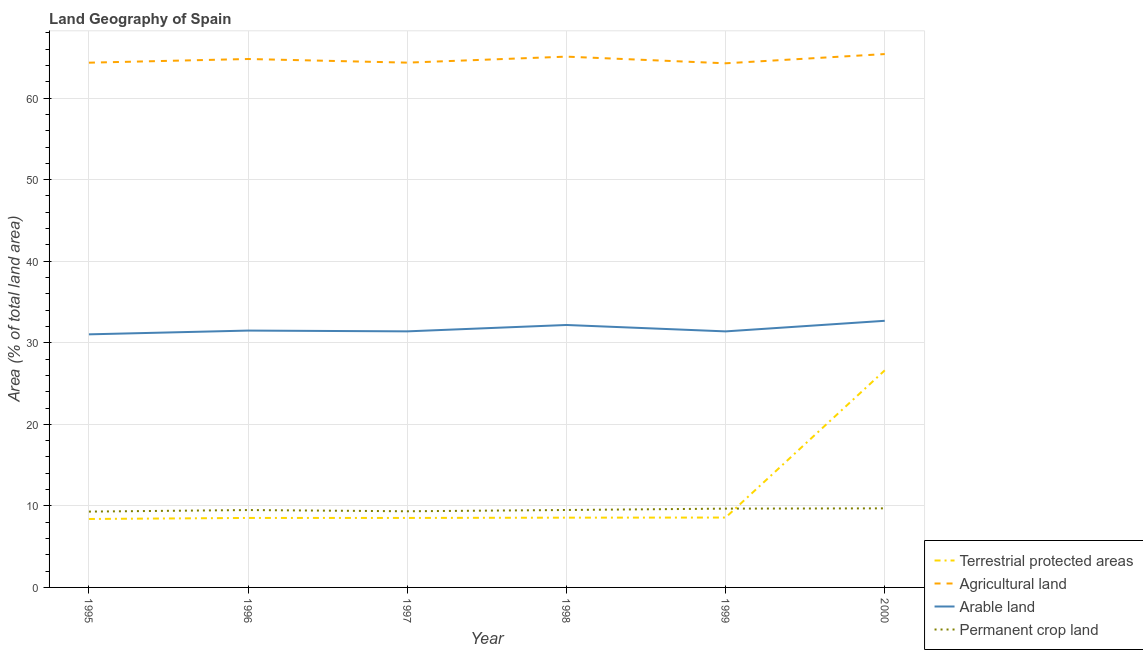What is the percentage of area under arable land in 1997?
Your answer should be very brief. 31.4. Across all years, what is the maximum percentage of land under terrestrial protection?
Keep it short and to the point. 26.62. Across all years, what is the minimum percentage of land under terrestrial protection?
Provide a succinct answer. 8.39. In which year was the percentage of area under permanent crop land maximum?
Ensure brevity in your answer.  2000. In which year was the percentage of area under permanent crop land minimum?
Your response must be concise. 1995. What is the total percentage of area under arable land in the graph?
Ensure brevity in your answer.  190.19. What is the difference between the percentage of area under agricultural land in 1995 and that in 1998?
Provide a short and direct response. -0.74. What is the difference between the percentage of area under agricultural land in 1997 and the percentage of area under permanent crop land in 1995?
Offer a very short reply. 55.05. What is the average percentage of area under arable land per year?
Your answer should be compact. 31.7. In the year 1996, what is the difference between the percentage of area under arable land and percentage of area under permanent crop land?
Offer a very short reply. 22.01. In how many years, is the percentage of area under agricultural land greater than 64 %?
Ensure brevity in your answer.  6. What is the ratio of the percentage of land under terrestrial protection in 1995 to that in 1996?
Ensure brevity in your answer.  0.98. Is the percentage of area under arable land in 1998 less than that in 2000?
Your response must be concise. Yes. What is the difference between the highest and the second highest percentage of area under agricultural land?
Give a very brief answer. 0.31. What is the difference between the highest and the lowest percentage of area under agricultural land?
Provide a succinct answer. 1.13. In how many years, is the percentage of area under arable land greater than the average percentage of area under arable land taken over all years?
Make the answer very short. 2. Does the percentage of land under terrestrial protection monotonically increase over the years?
Your answer should be compact. Yes. Is the percentage of area under permanent crop land strictly greater than the percentage of area under arable land over the years?
Your answer should be very brief. No. Is the percentage of area under agricultural land strictly less than the percentage of area under arable land over the years?
Provide a short and direct response. No. How many lines are there?
Your answer should be compact. 4. What is the difference between two consecutive major ticks on the Y-axis?
Your answer should be very brief. 10. Are the values on the major ticks of Y-axis written in scientific E-notation?
Provide a short and direct response. No. Does the graph contain grids?
Ensure brevity in your answer.  Yes. How many legend labels are there?
Ensure brevity in your answer.  4. What is the title of the graph?
Provide a succinct answer. Land Geography of Spain. What is the label or title of the Y-axis?
Your answer should be compact. Area (% of total land area). What is the Area (% of total land area) of Terrestrial protected areas in 1995?
Provide a short and direct response. 8.39. What is the Area (% of total land area) in Agricultural land in 1995?
Provide a succinct answer. 64.34. What is the Area (% of total land area) in Arable land in 1995?
Ensure brevity in your answer.  31.03. What is the Area (% of total land area) of Permanent crop land in 1995?
Provide a succinct answer. 9.3. What is the Area (% of total land area) in Terrestrial protected areas in 1996?
Make the answer very short. 8.52. What is the Area (% of total land area) in Agricultural land in 1996?
Keep it short and to the point. 64.79. What is the Area (% of total land area) in Arable land in 1996?
Provide a succinct answer. 31.49. What is the Area (% of total land area) of Permanent crop land in 1996?
Your answer should be very brief. 9.49. What is the Area (% of total land area) of Terrestrial protected areas in 1997?
Provide a short and direct response. 8.52. What is the Area (% of total land area) of Agricultural land in 1997?
Offer a terse response. 64.35. What is the Area (% of total land area) in Arable land in 1997?
Your answer should be very brief. 31.4. What is the Area (% of total land area) in Permanent crop land in 1997?
Your answer should be compact. 9.34. What is the Area (% of total land area) of Terrestrial protected areas in 1998?
Make the answer very short. 8.55. What is the Area (% of total land area) in Agricultural land in 1998?
Provide a short and direct response. 65.08. What is the Area (% of total land area) in Arable land in 1998?
Ensure brevity in your answer.  32.18. What is the Area (% of total land area) in Permanent crop land in 1998?
Your response must be concise. 9.49. What is the Area (% of total land area) of Terrestrial protected areas in 1999?
Keep it short and to the point. 8.57. What is the Area (% of total land area) in Agricultural land in 1999?
Provide a short and direct response. 64.27. What is the Area (% of total land area) of Arable land in 1999?
Provide a short and direct response. 31.39. What is the Area (% of total land area) in Permanent crop land in 1999?
Offer a very short reply. 9.66. What is the Area (% of total land area) in Terrestrial protected areas in 2000?
Your answer should be very brief. 26.62. What is the Area (% of total land area) in Agricultural land in 2000?
Your answer should be compact. 65.4. What is the Area (% of total land area) in Arable land in 2000?
Your response must be concise. 32.69. What is the Area (% of total land area) in Permanent crop land in 2000?
Offer a terse response. 9.69. Across all years, what is the maximum Area (% of total land area) in Terrestrial protected areas?
Your answer should be very brief. 26.62. Across all years, what is the maximum Area (% of total land area) in Agricultural land?
Offer a terse response. 65.4. Across all years, what is the maximum Area (% of total land area) of Arable land?
Provide a short and direct response. 32.69. Across all years, what is the maximum Area (% of total land area) of Permanent crop land?
Your answer should be very brief. 9.69. Across all years, what is the minimum Area (% of total land area) in Terrestrial protected areas?
Make the answer very short. 8.39. Across all years, what is the minimum Area (% of total land area) in Agricultural land?
Offer a terse response. 64.27. Across all years, what is the minimum Area (% of total land area) of Arable land?
Provide a succinct answer. 31.03. Across all years, what is the minimum Area (% of total land area) in Permanent crop land?
Your answer should be very brief. 9.3. What is the total Area (% of total land area) in Terrestrial protected areas in the graph?
Your response must be concise. 69.17. What is the total Area (% of total land area) in Agricultural land in the graph?
Your answer should be very brief. 388.22. What is the total Area (% of total land area) in Arable land in the graph?
Your answer should be compact. 190.19. What is the total Area (% of total land area) of Permanent crop land in the graph?
Keep it short and to the point. 56.98. What is the difference between the Area (% of total land area) in Terrestrial protected areas in 1995 and that in 1996?
Provide a succinct answer. -0.13. What is the difference between the Area (% of total land area) of Agricultural land in 1995 and that in 1996?
Offer a terse response. -0.45. What is the difference between the Area (% of total land area) of Arable land in 1995 and that in 1996?
Give a very brief answer. -0.46. What is the difference between the Area (% of total land area) of Permanent crop land in 1995 and that in 1996?
Your answer should be very brief. -0.19. What is the difference between the Area (% of total land area) in Terrestrial protected areas in 1995 and that in 1997?
Ensure brevity in your answer.  -0.13. What is the difference between the Area (% of total land area) in Agricultural land in 1995 and that in 1997?
Offer a very short reply. -0.01. What is the difference between the Area (% of total land area) of Arable land in 1995 and that in 1997?
Your answer should be compact. -0.37. What is the difference between the Area (% of total land area) of Permanent crop land in 1995 and that in 1997?
Your answer should be very brief. -0.04. What is the difference between the Area (% of total land area) in Terrestrial protected areas in 1995 and that in 1998?
Provide a succinct answer. -0.16. What is the difference between the Area (% of total land area) of Agricultural land in 1995 and that in 1998?
Provide a short and direct response. -0.74. What is the difference between the Area (% of total land area) in Arable land in 1995 and that in 1998?
Offer a terse response. -1.15. What is the difference between the Area (% of total land area) in Permanent crop land in 1995 and that in 1998?
Your answer should be very brief. -0.2. What is the difference between the Area (% of total land area) in Terrestrial protected areas in 1995 and that in 1999?
Provide a succinct answer. -0.18. What is the difference between the Area (% of total land area) of Agricultural land in 1995 and that in 1999?
Ensure brevity in your answer.  0.07. What is the difference between the Area (% of total land area) in Arable land in 1995 and that in 1999?
Ensure brevity in your answer.  -0.36. What is the difference between the Area (% of total land area) of Permanent crop land in 1995 and that in 1999?
Give a very brief answer. -0.36. What is the difference between the Area (% of total land area) of Terrestrial protected areas in 1995 and that in 2000?
Your response must be concise. -18.23. What is the difference between the Area (% of total land area) in Agricultural land in 1995 and that in 2000?
Ensure brevity in your answer.  -1.06. What is the difference between the Area (% of total land area) in Arable land in 1995 and that in 2000?
Offer a terse response. -1.66. What is the difference between the Area (% of total land area) of Permanent crop land in 1995 and that in 2000?
Offer a terse response. -0.4. What is the difference between the Area (% of total land area) of Terrestrial protected areas in 1996 and that in 1997?
Your response must be concise. -0. What is the difference between the Area (% of total land area) of Agricultural land in 1996 and that in 1997?
Your answer should be very brief. 0.45. What is the difference between the Area (% of total land area) in Arable land in 1996 and that in 1997?
Provide a succinct answer. 0.1. What is the difference between the Area (% of total land area) of Permanent crop land in 1996 and that in 1997?
Your answer should be compact. 0.15. What is the difference between the Area (% of total land area) in Terrestrial protected areas in 1996 and that in 1998?
Provide a short and direct response. -0.03. What is the difference between the Area (% of total land area) in Agricultural land in 1996 and that in 1998?
Your answer should be compact. -0.29. What is the difference between the Area (% of total land area) of Arable land in 1996 and that in 1998?
Make the answer very short. -0.68. What is the difference between the Area (% of total land area) of Permanent crop land in 1996 and that in 1998?
Your answer should be compact. -0.01. What is the difference between the Area (% of total land area) in Terrestrial protected areas in 1996 and that in 1999?
Provide a succinct answer. -0.05. What is the difference between the Area (% of total land area) of Agricultural land in 1996 and that in 1999?
Offer a very short reply. 0.53. What is the difference between the Area (% of total land area) in Arable land in 1996 and that in 1999?
Your answer should be very brief. 0.1. What is the difference between the Area (% of total land area) in Permanent crop land in 1996 and that in 1999?
Make the answer very short. -0.17. What is the difference between the Area (% of total land area) of Terrestrial protected areas in 1996 and that in 2000?
Your answer should be very brief. -18.1. What is the difference between the Area (% of total land area) in Agricultural land in 1996 and that in 2000?
Provide a succinct answer. -0.6. What is the difference between the Area (% of total land area) in Arable land in 1996 and that in 2000?
Your answer should be very brief. -1.2. What is the difference between the Area (% of total land area) of Permanent crop land in 1996 and that in 2000?
Your answer should be very brief. -0.21. What is the difference between the Area (% of total land area) of Terrestrial protected areas in 1997 and that in 1998?
Provide a short and direct response. -0.03. What is the difference between the Area (% of total land area) in Agricultural land in 1997 and that in 1998?
Your response must be concise. -0.74. What is the difference between the Area (% of total land area) of Arable land in 1997 and that in 1998?
Offer a terse response. -0.78. What is the difference between the Area (% of total land area) in Permanent crop land in 1997 and that in 1998?
Provide a succinct answer. -0.16. What is the difference between the Area (% of total land area) in Terrestrial protected areas in 1997 and that in 1999?
Your answer should be very brief. -0.05. What is the difference between the Area (% of total land area) in Arable land in 1997 and that in 1999?
Keep it short and to the point. 0. What is the difference between the Area (% of total land area) in Permanent crop land in 1997 and that in 1999?
Keep it short and to the point. -0.32. What is the difference between the Area (% of total land area) in Terrestrial protected areas in 1997 and that in 2000?
Make the answer very short. -18.1. What is the difference between the Area (% of total land area) of Agricultural land in 1997 and that in 2000?
Provide a short and direct response. -1.05. What is the difference between the Area (% of total land area) in Arable land in 1997 and that in 2000?
Provide a succinct answer. -1.29. What is the difference between the Area (% of total land area) in Permanent crop land in 1997 and that in 2000?
Your answer should be compact. -0.36. What is the difference between the Area (% of total land area) in Terrestrial protected areas in 1998 and that in 1999?
Your answer should be very brief. -0.01. What is the difference between the Area (% of total land area) of Agricultural land in 1998 and that in 1999?
Provide a succinct answer. 0.82. What is the difference between the Area (% of total land area) in Arable land in 1998 and that in 1999?
Your answer should be very brief. 0.78. What is the difference between the Area (% of total land area) of Permanent crop land in 1998 and that in 1999?
Provide a short and direct response. -0.17. What is the difference between the Area (% of total land area) in Terrestrial protected areas in 1998 and that in 2000?
Your answer should be very brief. -18.06. What is the difference between the Area (% of total land area) in Agricultural land in 1998 and that in 2000?
Your response must be concise. -0.31. What is the difference between the Area (% of total land area) in Arable land in 1998 and that in 2000?
Your answer should be very brief. -0.51. What is the difference between the Area (% of total land area) of Permanent crop land in 1998 and that in 2000?
Ensure brevity in your answer.  -0.2. What is the difference between the Area (% of total land area) in Terrestrial protected areas in 1999 and that in 2000?
Your answer should be compact. -18.05. What is the difference between the Area (% of total land area) of Agricultural land in 1999 and that in 2000?
Make the answer very short. -1.13. What is the difference between the Area (% of total land area) in Arable land in 1999 and that in 2000?
Give a very brief answer. -1.3. What is the difference between the Area (% of total land area) in Permanent crop land in 1999 and that in 2000?
Provide a short and direct response. -0.03. What is the difference between the Area (% of total land area) of Terrestrial protected areas in 1995 and the Area (% of total land area) of Agricultural land in 1996?
Give a very brief answer. -56.4. What is the difference between the Area (% of total land area) in Terrestrial protected areas in 1995 and the Area (% of total land area) in Arable land in 1996?
Keep it short and to the point. -23.1. What is the difference between the Area (% of total land area) in Terrestrial protected areas in 1995 and the Area (% of total land area) in Permanent crop land in 1996?
Make the answer very short. -1.1. What is the difference between the Area (% of total land area) of Agricultural land in 1995 and the Area (% of total land area) of Arable land in 1996?
Offer a terse response. 32.85. What is the difference between the Area (% of total land area) of Agricultural land in 1995 and the Area (% of total land area) of Permanent crop land in 1996?
Provide a succinct answer. 54.85. What is the difference between the Area (% of total land area) in Arable land in 1995 and the Area (% of total land area) in Permanent crop land in 1996?
Your answer should be very brief. 21.54. What is the difference between the Area (% of total land area) in Terrestrial protected areas in 1995 and the Area (% of total land area) in Agricultural land in 1997?
Your answer should be very brief. -55.95. What is the difference between the Area (% of total land area) in Terrestrial protected areas in 1995 and the Area (% of total land area) in Arable land in 1997?
Ensure brevity in your answer.  -23.01. What is the difference between the Area (% of total land area) of Terrestrial protected areas in 1995 and the Area (% of total land area) of Permanent crop land in 1997?
Give a very brief answer. -0.95. What is the difference between the Area (% of total land area) of Agricultural land in 1995 and the Area (% of total land area) of Arable land in 1997?
Your response must be concise. 32.94. What is the difference between the Area (% of total land area) of Agricultural land in 1995 and the Area (% of total land area) of Permanent crop land in 1997?
Provide a short and direct response. 55. What is the difference between the Area (% of total land area) in Arable land in 1995 and the Area (% of total land area) in Permanent crop land in 1997?
Your answer should be compact. 21.69. What is the difference between the Area (% of total land area) of Terrestrial protected areas in 1995 and the Area (% of total land area) of Agricultural land in 1998?
Keep it short and to the point. -56.69. What is the difference between the Area (% of total land area) of Terrestrial protected areas in 1995 and the Area (% of total land area) of Arable land in 1998?
Give a very brief answer. -23.79. What is the difference between the Area (% of total land area) in Terrestrial protected areas in 1995 and the Area (% of total land area) in Permanent crop land in 1998?
Your answer should be very brief. -1.1. What is the difference between the Area (% of total land area) of Agricultural land in 1995 and the Area (% of total land area) of Arable land in 1998?
Provide a short and direct response. 32.16. What is the difference between the Area (% of total land area) in Agricultural land in 1995 and the Area (% of total land area) in Permanent crop land in 1998?
Ensure brevity in your answer.  54.85. What is the difference between the Area (% of total land area) of Arable land in 1995 and the Area (% of total land area) of Permanent crop land in 1998?
Offer a terse response. 21.54. What is the difference between the Area (% of total land area) of Terrestrial protected areas in 1995 and the Area (% of total land area) of Agricultural land in 1999?
Provide a succinct answer. -55.87. What is the difference between the Area (% of total land area) in Terrestrial protected areas in 1995 and the Area (% of total land area) in Arable land in 1999?
Make the answer very short. -23. What is the difference between the Area (% of total land area) of Terrestrial protected areas in 1995 and the Area (% of total land area) of Permanent crop land in 1999?
Your answer should be very brief. -1.27. What is the difference between the Area (% of total land area) in Agricultural land in 1995 and the Area (% of total land area) in Arable land in 1999?
Provide a succinct answer. 32.95. What is the difference between the Area (% of total land area) of Agricultural land in 1995 and the Area (% of total land area) of Permanent crop land in 1999?
Offer a very short reply. 54.68. What is the difference between the Area (% of total land area) of Arable land in 1995 and the Area (% of total land area) of Permanent crop land in 1999?
Your answer should be compact. 21.37. What is the difference between the Area (% of total land area) in Terrestrial protected areas in 1995 and the Area (% of total land area) in Agricultural land in 2000?
Your answer should be very brief. -57. What is the difference between the Area (% of total land area) in Terrestrial protected areas in 1995 and the Area (% of total land area) in Arable land in 2000?
Your answer should be compact. -24.3. What is the difference between the Area (% of total land area) in Terrestrial protected areas in 1995 and the Area (% of total land area) in Permanent crop land in 2000?
Your response must be concise. -1.3. What is the difference between the Area (% of total land area) in Agricultural land in 1995 and the Area (% of total land area) in Arable land in 2000?
Provide a short and direct response. 31.65. What is the difference between the Area (% of total land area) of Agricultural land in 1995 and the Area (% of total land area) of Permanent crop land in 2000?
Give a very brief answer. 54.65. What is the difference between the Area (% of total land area) of Arable land in 1995 and the Area (% of total land area) of Permanent crop land in 2000?
Provide a succinct answer. 21.34. What is the difference between the Area (% of total land area) of Terrestrial protected areas in 1996 and the Area (% of total land area) of Agricultural land in 1997?
Offer a very short reply. -55.83. What is the difference between the Area (% of total land area) of Terrestrial protected areas in 1996 and the Area (% of total land area) of Arable land in 1997?
Provide a succinct answer. -22.88. What is the difference between the Area (% of total land area) of Terrestrial protected areas in 1996 and the Area (% of total land area) of Permanent crop land in 1997?
Make the answer very short. -0.82. What is the difference between the Area (% of total land area) of Agricultural land in 1996 and the Area (% of total land area) of Arable land in 1997?
Your response must be concise. 33.39. What is the difference between the Area (% of total land area) of Agricultural land in 1996 and the Area (% of total land area) of Permanent crop land in 1997?
Offer a terse response. 55.45. What is the difference between the Area (% of total land area) in Arable land in 1996 and the Area (% of total land area) in Permanent crop land in 1997?
Make the answer very short. 22.16. What is the difference between the Area (% of total land area) of Terrestrial protected areas in 1996 and the Area (% of total land area) of Agricultural land in 1998?
Give a very brief answer. -56.56. What is the difference between the Area (% of total land area) of Terrestrial protected areas in 1996 and the Area (% of total land area) of Arable land in 1998?
Your answer should be very brief. -23.66. What is the difference between the Area (% of total land area) of Terrestrial protected areas in 1996 and the Area (% of total land area) of Permanent crop land in 1998?
Ensure brevity in your answer.  -0.97. What is the difference between the Area (% of total land area) in Agricultural land in 1996 and the Area (% of total land area) in Arable land in 1998?
Ensure brevity in your answer.  32.61. What is the difference between the Area (% of total land area) of Agricultural land in 1996 and the Area (% of total land area) of Permanent crop land in 1998?
Give a very brief answer. 55.3. What is the difference between the Area (% of total land area) of Arable land in 1996 and the Area (% of total land area) of Permanent crop land in 1998?
Make the answer very short. 22. What is the difference between the Area (% of total land area) in Terrestrial protected areas in 1996 and the Area (% of total land area) in Agricultural land in 1999?
Your answer should be very brief. -55.75. What is the difference between the Area (% of total land area) in Terrestrial protected areas in 1996 and the Area (% of total land area) in Arable land in 1999?
Your answer should be very brief. -22.87. What is the difference between the Area (% of total land area) of Terrestrial protected areas in 1996 and the Area (% of total land area) of Permanent crop land in 1999?
Ensure brevity in your answer.  -1.14. What is the difference between the Area (% of total land area) in Agricultural land in 1996 and the Area (% of total land area) in Arable land in 1999?
Your answer should be compact. 33.4. What is the difference between the Area (% of total land area) of Agricultural land in 1996 and the Area (% of total land area) of Permanent crop land in 1999?
Give a very brief answer. 55.13. What is the difference between the Area (% of total land area) of Arable land in 1996 and the Area (% of total land area) of Permanent crop land in 1999?
Your answer should be very brief. 21.83. What is the difference between the Area (% of total land area) in Terrestrial protected areas in 1996 and the Area (% of total land area) in Agricultural land in 2000?
Your response must be concise. -56.88. What is the difference between the Area (% of total land area) of Terrestrial protected areas in 1996 and the Area (% of total land area) of Arable land in 2000?
Keep it short and to the point. -24.17. What is the difference between the Area (% of total land area) of Terrestrial protected areas in 1996 and the Area (% of total land area) of Permanent crop land in 2000?
Your answer should be compact. -1.17. What is the difference between the Area (% of total land area) in Agricultural land in 1996 and the Area (% of total land area) in Arable land in 2000?
Your response must be concise. 32.1. What is the difference between the Area (% of total land area) in Agricultural land in 1996 and the Area (% of total land area) in Permanent crop land in 2000?
Offer a terse response. 55.1. What is the difference between the Area (% of total land area) of Arable land in 1996 and the Area (% of total land area) of Permanent crop land in 2000?
Your answer should be compact. 21.8. What is the difference between the Area (% of total land area) in Terrestrial protected areas in 1997 and the Area (% of total land area) in Agricultural land in 1998?
Provide a short and direct response. -56.56. What is the difference between the Area (% of total land area) in Terrestrial protected areas in 1997 and the Area (% of total land area) in Arable land in 1998?
Ensure brevity in your answer.  -23.66. What is the difference between the Area (% of total land area) of Terrestrial protected areas in 1997 and the Area (% of total land area) of Permanent crop land in 1998?
Keep it short and to the point. -0.97. What is the difference between the Area (% of total land area) in Agricultural land in 1997 and the Area (% of total land area) in Arable land in 1998?
Your answer should be very brief. 32.17. What is the difference between the Area (% of total land area) in Agricultural land in 1997 and the Area (% of total land area) in Permanent crop land in 1998?
Your answer should be compact. 54.85. What is the difference between the Area (% of total land area) of Arable land in 1997 and the Area (% of total land area) of Permanent crop land in 1998?
Keep it short and to the point. 21.9. What is the difference between the Area (% of total land area) in Terrestrial protected areas in 1997 and the Area (% of total land area) in Agricultural land in 1999?
Your response must be concise. -55.75. What is the difference between the Area (% of total land area) of Terrestrial protected areas in 1997 and the Area (% of total land area) of Arable land in 1999?
Give a very brief answer. -22.87. What is the difference between the Area (% of total land area) in Terrestrial protected areas in 1997 and the Area (% of total land area) in Permanent crop land in 1999?
Provide a short and direct response. -1.14. What is the difference between the Area (% of total land area) of Agricultural land in 1997 and the Area (% of total land area) of Arable land in 1999?
Your answer should be compact. 32.95. What is the difference between the Area (% of total land area) of Agricultural land in 1997 and the Area (% of total land area) of Permanent crop land in 1999?
Offer a very short reply. 54.68. What is the difference between the Area (% of total land area) in Arable land in 1997 and the Area (% of total land area) in Permanent crop land in 1999?
Your response must be concise. 21.74. What is the difference between the Area (% of total land area) in Terrestrial protected areas in 1997 and the Area (% of total land area) in Agricultural land in 2000?
Make the answer very short. -56.88. What is the difference between the Area (% of total land area) of Terrestrial protected areas in 1997 and the Area (% of total land area) of Arable land in 2000?
Offer a terse response. -24.17. What is the difference between the Area (% of total land area) of Terrestrial protected areas in 1997 and the Area (% of total land area) of Permanent crop land in 2000?
Make the answer very short. -1.17. What is the difference between the Area (% of total land area) of Agricultural land in 1997 and the Area (% of total land area) of Arable land in 2000?
Give a very brief answer. 31.65. What is the difference between the Area (% of total land area) of Agricultural land in 1997 and the Area (% of total land area) of Permanent crop land in 2000?
Provide a short and direct response. 54.65. What is the difference between the Area (% of total land area) in Arable land in 1997 and the Area (% of total land area) in Permanent crop land in 2000?
Keep it short and to the point. 21.7. What is the difference between the Area (% of total land area) in Terrestrial protected areas in 1998 and the Area (% of total land area) in Agricultural land in 1999?
Offer a terse response. -55.71. What is the difference between the Area (% of total land area) of Terrestrial protected areas in 1998 and the Area (% of total land area) of Arable land in 1999?
Provide a succinct answer. -22.84. What is the difference between the Area (% of total land area) in Terrestrial protected areas in 1998 and the Area (% of total land area) in Permanent crop land in 1999?
Give a very brief answer. -1.11. What is the difference between the Area (% of total land area) of Agricultural land in 1998 and the Area (% of total land area) of Arable land in 1999?
Your answer should be compact. 33.69. What is the difference between the Area (% of total land area) in Agricultural land in 1998 and the Area (% of total land area) in Permanent crop land in 1999?
Give a very brief answer. 55.42. What is the difference between the Area (% of total land area) in Arable land in 1998 and the Area (% of total land area) in Permanent crop land in 1999?
Ensure brevity in your answer.  22.52. What is the difference between the Area (% of total land area) of Terrestrial protected areas in 1998 and the Area (% of total land area) of Agricultural land in 2000?
Keep it short and to the point. -56.84. What is the difference between the Area (% of total land area) in Terrestrial protected areas in 1998 and the Area (% of total land area) in Arable land in 2000?
Your answer should be compact. -24.14. What is the difference between the Area (% of total land area) of Terrestrial protected areas in 1998 and the Area (% of total land area) of Permanent crop land in 2000?
Provide a short and direct response. -1.14. What is the difference between the Area (% of total land area) of Agricultural land in 1998 and the Area (% of total land area) of Arable land in 2000?
Provide a short and direct response. 32.39. What is the difference between the Area (% of total land area) in Agricultural land in 1998 and the Area (% of total land area) in Permanent crop land in 2000?
Provide a short and direct response. 55.39. What is the difference between the Area (% of total land area) in Arable land in 1998 and the Area (% of total land area) in Permanent crop land in 2000?
Your answer should be very brief. 22.48. What is the difference between the Area (% of total land area) of Terrestrial protected areas in 1999 and the Area (% of total land area) of Agricultural land in 2000?
Your answer should be very brief. -56.83. What is the difference between the Area (% of total land area) of Terrestrial protected areas in 1999 and the Area (% of total land area) of Arable land in 2000?
Provide a short and direct response. -24.12. What is the difference between the Area (% of total land area) in Terrestrial protected areas in 1999 and the Area (% of total land area) in Permanent crop land in 2000?
Your response must be concise. -1.13. What is the difference between the Area (% of total land area) of Agricultural land in 1999 and the Area (% of total land area) of Arable land in 2000?
Your answer should be very brief. 31.57. What is the difference between the Area (% of total land area) of Agricultural land in 1999 and the Area (% of total land area) of Permanent crop land in 2000?
Your answer should be very brief. 54.57. What is the difference between the Area (% of total land area) in Arable land in 1999 and the Area (% of total land area) in Permanent crop land in 2000?
Your answer should be very brief. 21.7. What is the average Area (% of total land area) in Terrestrial protected areas per year?
Keep it short and to the point. 11.53. What is the average Area (% of total land area) in Agricultural land per year?
Give a very brief answer. 64.7. What is the average Area (% of total land area) of Arable land per year?
Your answer should be very brief. 31.7. What is the average Area (% of total land area) of Permanent crop land per year?
Provide a succinct answer. 9.5. In the year 1995, what is the difference between the Area (% of total land area) of Terrestrial protected areas and Area (% of total land area) of Agricultural land?
Keep it short and to the point. -55.95. In the year 1995, what is the difference between the Area (% of total land area) of Terrestrial protected areas and Area (% of total land area) of Arable land?
Ensure brevity in your answer.  -22.64. In the year 1995, what is the difference between the Area (% of total land area) in Terrestrial protected areas and Area (% of total land area) in Permanent crop land?
Ensure brevity in your answer.  -0.91. In the year 1995, what is the difference between the Area (% of total land area) in Agricultural land and Area (% of total land area) in Arable land?
Give a very brief answer. 33.31. In the year 1995, what is the difference between the Area (% of total land area) in Agricultural land and Area (% of total land area) in Permanent crop land?
Your answer should be compact. 55.04. In the year 1995, what is the difference between the Area (% of total land area) in Arable land and Area (% of total land area) in Permanent crop land?
Your answer should be very brief. 21.73. In the year 1996, what is the difference between the Area (% of total land area) in Terrestrial protected areas and Area (% of total land area) in Agricultural land?
Provide a short and direct response. -56.27. In the year 1996, what is the difference between the Area (% of total land area) in Terrestrial protected areas and Area (% of total land area) in Arable land?
Offer a very short reply. -22.97. In the year 1996, what is the difference between the Area (% of total land area) of Terrestrial protected areas and Area (% of total land area) of Permanent crop land?
Make the answer very short. -0.97. In the year 1996, what is the difference between the Area (% of total land area) of Agricultural land and Area (% of total land area) of Arable land?
Offer a terse response. 33.3. In the year 1996, what is the difference between the Area (% of total land area) of Agricultural land and Area (% of total land area) of Permanent crop land?
Your answer should be very brief. 55.3. In the year 1996, what is the difference between the Area (% of total land area) of Arable land and Area (% of total land area) of Permanent crop land?
Ensure brevity in your answer.  22.01. In the year 1997, what is the difference between the Area (% of total land area) of Terrestrial protected areas and Area (% of total land area) of Agricultural land?
Your answer should be compact. -55.83. In the year 1997, what is the difference between the Area (% of total land area) of Terrestrial protected areas and Area (% of total land area) of Arable land?
Keep it short and to the point. -22.88. In the year 1997, what is the difference between the Area (% of total land area) in Terrestrial protected areas and Area (% of total land area) in Permanent crop land?
Provide a short and direct response. -0.82. In the year 1997, what is the difference between the Area (% of total land area) in Agricultural land and Area (% of total land area) in Arable land?
Offer a very short reply. 32.95. In the year 1997, what is the difference between the Area (% of total land area) of Agricultural land and Area (% of total land area) of Permanent crop land?
Offer a very short reply. 55.01. In the year 1997, what is the difference between the Area (% of total land area) of Arable land and Area (% of total land area) of Permanent crop land?
Offer a very short reply. 22.06. In the year 1998, what is the difference between the Area (% of total land area) of Terrestrial protected areas and Area (% of total land area) of Agricultural land?
Your answer should be very brief. -56.53. In the year 1998, what is the difference between the Area (% of total land area) in Terrestrial protected areas and Area (% of total land area) in Arable land?
Provide a short and direct response. -23.62. In the year 1998, what is the difference between the Area (% of total land area) of Terrestrial protected areas and Area (% of total land area) of Permanent crop land?
Ensure brevity in your answer.  -0.94. In the year 1998, what is the difference between the Area (% of total land area) in Agricultural land and Area (% of total land area) in Arable land?
Keep it short and to the point. 32.9. In the year 1998, what is the difference between the Area (% of total land area) of Agricultural land and Area (% of total land area) of Permanent crop land?
Offer a very short reply. 55.59. In the year 1998, what is the difference between the Area (% of total land area) in Arable land and Area (% of total land area) in Permanent crop land?
Ensure brevity in your answer.  22.68. In the year 1999, what is the difference between the Area (% of total land area) in Terrestrial protected areas and Area (% of total land area) in Agricultural land?
Give a very brief answer. -55.7. In the year 1999, what is the difference between the Area (% of total land area) of Terrestrial protected areas and Area (% of total land area) of Arable land?
Your answer should be compact. -22.83. In the year 1999, what is the difference between the Area (% of total land area) in Terrestrial protected areas and Area (% of total land area) in Permanent crop land?
Provide a short and direct response. -1.09. In the year 1999, what is the difference between the Area (% of total land area) of Agricultural land and Area (% of total land area) of Arable land?
Your answer should be very brief. 32.87. In the year 1999, what is the difference between the Area (% of total land area) of Agricultural land and Area (% of total land area) of Permanent crop land?
Keep it short and to the point. 54.6. In the year 1999, what is the difference between the Area (% of total land area) in Arable land and Area (% of total land area) in Permanent crop land?
Ensure brevity in your answer.  21.73. In the year 2000, what is the difference between the Area (% of total land area) in Terrestrial protected areas and Area (% of total land area) in Agricultural land?
Keep it short and to the point. -38.78. In the year 2000, what is the difference between the Area (% of total land area) in Terrestrial protected areas and Area (% of total land area) in Arable land?
Offer a very short reply. -6.07. In the year 2000, what is the difference between the Area (% of total land area) in Terrestrial protected areas and Area (% of total land area) in Permanent crop land?
Your response must be concise. 16.92. In the year 2000, what is the difference between the Area (% of total land area) in Agricultural land and Area (% of total land area) in Arable land?
Provide a short and direct response. 32.7. In the year 2000, what is the difference between the Area (% of total land area) in Agricultural land and Area (% of total land area) in Permanent crop land?
Offer a very short reply. 55.7. In the year 2000, what is the difference between the Area (% of total land area) of Arable land and Area (% of total land area) of Permanent crop land?
Keep it short and to the point. 23. What is the ratio of the Area (% of total land area) in Terrestrial protected areas in 1995 to that in 1996?
Offer a terse response. 0.98. What is the ratio of the Area (% of total land area) of Permanent crop land in 1995 to that in 1996?
Give a very brief answer. 0.98. What is the ratio of the Area (% of total land area) of Agricultural land in 1995 to that in 1997?
Offer a terse response. 1. What is the ratio of the Area (% of total land area) of Arable land in 1995 to that in 1997?
Give a very brief answer. 0.99. What is the ratio of the Area (% of total land area) of Arable land in 1995 to that in 1998?
Give a very brief answer. 0.96. What is the ratio of the Area (% of total land area) of Permanent crop land in 1995 to that in 1998?
Keep it short and to the point. 0.98. What is the ratio of the Area (% of total land area) in Terrestrial protected areas in 1995 to that in 1999?
Give a very brief answer. 0.98. What is the ratio of the Area (% of total land area) in Arable land in 1995 to that in 1999?
Your answer should be very brief. 0.99. What is the ratio of the Area (% of total land area) of Permanent crop land in 1995 to that in 1999?
Offer a terse response. 0.96. What is the ratio of the Area (% of total land area) in Terrestrial protected areas in 1995 to that in 2000?
Provide a succinct answer. 0.32. What is the ratio of the Area (% of total land area) of Agricultural land in 1995 to that in 2000?
Provide a succinct answer. 0.98. What is the ratio of the Area (% of total land area) in Arable land in 1995 to that in 2000?
Make the answer very short. 0.95. What is the ratio of the Area (% of total land area) in Permanent crop land in 1995 to that in 2000?
Offer a very short reply. 0.96. What is the ratio of the Area (% of total land area) of Terrestrial protected areas in 1996 to that in 1997?
Make the answer very short. 1. What is the ratio of the Area (% of total land area) of Permanent crop land in 1996 to that in 1997?
Your response must be concise. 1.02. What is the ratio of the Area (% of total land area) in Terrestrial protected areas in 1996 to that in 1998?
Give a very brief answer. 1. What is the ratio of the Area (% of total land area) of Agricultural land in 1996 to that in 1998?
Provide a succinct answer. 1. What is the ratio of the Area (% of total land area) in Arable land in 1996 to that in 1998?
Give a very brief answer. 0.98. What is the ratio of the Area (% of total land area) of Terrestrial protected areas in 1996 to that in 1999?
Make the answer very short. 0.99. What is the ratio of the Area (% of total land area) of Agricultural land in 1996 to that in 1999?
Keep it short and to the point. 1.01. What is the ratio of the Area (% of total land area) in Permanent crop land in 1996 to that in 1999?
Make the answer very short. 0.98. What is the ratio of the Area (% of total land area) in Terrestrial protected areas in 1996 to that in 2000?
Your response must be concise. 0.32. What is the ratio of the Area (% of total land area) of Arable land in 1996 to that in 2000?
Your answer should be compact. 0.96. What is the ratio of the Area (% of total land area) in Permanent crop land in 1996 to that in 2000?
Keep it short and to the point. 0.98. What is the ratio of the Area (% of total land area) of Agricultural land in 1997 to that in 1998?
Provide a succinct answer. 0.99. What is the ratio of the Area (% of total land area) of Arable land in 1997 to that in 1998?
Make the answer very short. 0.98. What is the ratio of the Area (% of total land area) of Permanent crop land in 1997 to that in 1998?
Provide a succinct answer. 0.98. What is the ratio of the Area (% of total land area) in Permanent crop land in 1997 to that in 1999?
Provide a short and direct response. 0.97. What is the ratio of the Area (% of total land area) of Terrestrial protected areas in 1997 to that in 2000?
Keep it short and to the point. 0.32. What is the ratio of the Area (% of total land area) in Agricultural land in 1997 to that in 2000?
Offer a very short reply. 0.98. What is the ratio of the Area (% of total land area) of Arable land in 1997 to that in 2000?
Offer a very short reply. 0.96. What is the ratio of the Area (% of total land area) of Permanent crop land in 1997 to that in 2000?
Offer a very short reply. 0.96. What is the ratio of the Area (% of total land area) of Terrestrial protected areas in 1998 to that in 1999?
Your answer should be very brief. 1. What is the ratio of the Area (% of total land area) of Agricultural land in 1998 to that in 1999?
Provide a succinct answer. 1.01. What is the ratio of the Area (% of total land area) in Arable land in 1998 to that in 1999?
Give a very brief answer. 1.02. What is the ratio of the Area (% of total land area) of Permanent crop land in 1998 to that in 1999?
Keep it short and to the point. 0.98. What is the ratio of the Area (% of total land area) in Terrestrial protected areas in 1998 to that in 2000?
Make the answer very short. 0.32. What is the ratio of the Area (% of total land area) of Agricultural land in 1998 to that in 2000?
Keep it short and to the point. 1. What is the ratio of the Area (% of total land area) in Arable land in 1998 to that in 2000?
Your answer should be very brief. 0.98. What is the ratio of the Area (% of total land area) of Permanent crop land in 1998 to that in 2000?
Keep it short and to the point. 0.98. What is the ratio of the Area (% of total land area) in Terrestrial protected areas in 1999 to that in 2000?
Your answer should be compact. 0.32. What is the ratio of the Area (% of total land area) of Agricultural land in 1999 to that in 2000?
Provide a short and direct response. 0.98. What is the ratio of the Area (% of total land area) in Arable land in 1999 to that in 2000?
Provide a short and direct response. 0.96. What is the difference between the highest and the second highest Area (% of total land area) of Terrestrial protected areas?
Offer a very short reply. 18.05. What is the difference between the highest and the second highest Area (% of total land area) of Agricultural land?
Offer a very short reply. 0.31. What is the difference between the highest and the second highest Area (% of total land area) of Arable land?
Provide a succinct answer. 0.51. What is the difference between the highest and the second highest Area (% of total land area) in Permanent crop land?
Keep it short and to the point. 0.03. What is the difference between the highest and the lowest Area (% of total land area) of Terrestrial protected areas?
Keep it short and to the point. 18.23. What is the difference between the highest and the lowest Area (% of total land area) in Agricultural land?
Your answer should be very brief. 1.13. What is the difference between the highest and the lowest Area (% of total land area) in Arable land?
Offer a very short reply. 1.66. What is the difference between the highest and the lowest Area (% of total land area) of Permanent crop land?
Make the answer very short. 0.4. 